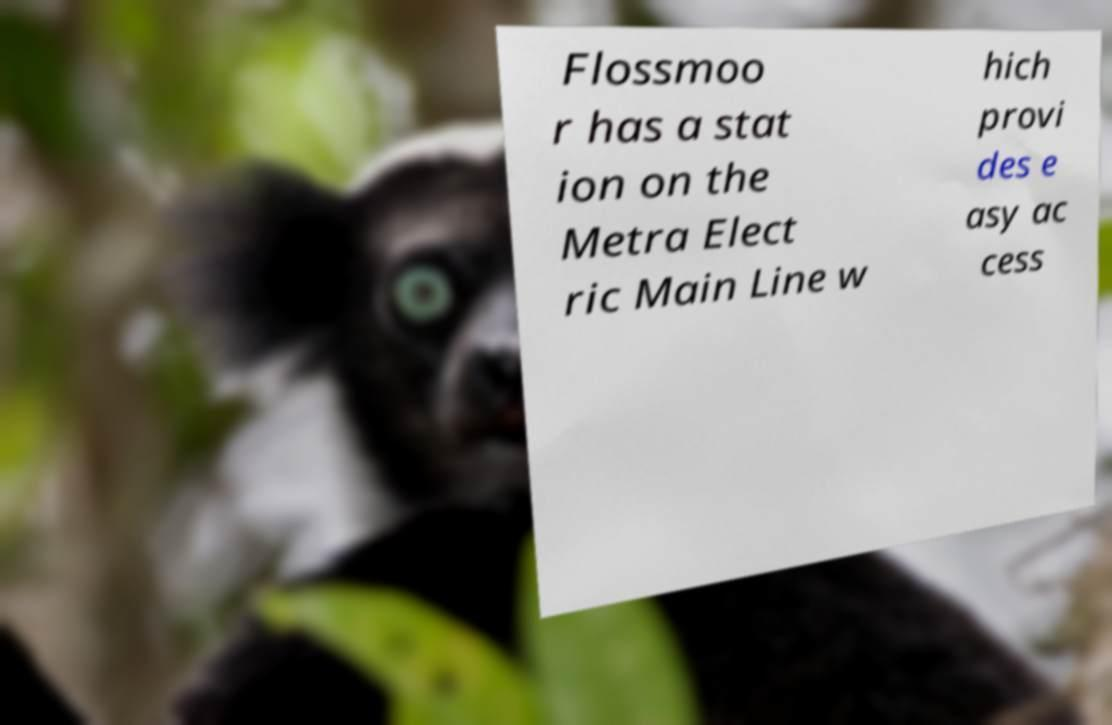Could you assist in decoding the text presented in this image and type it out clearly? Flossmoo r has a stat ion on the Metra Elect ric Main Line w hich provi des e asy ac cess 